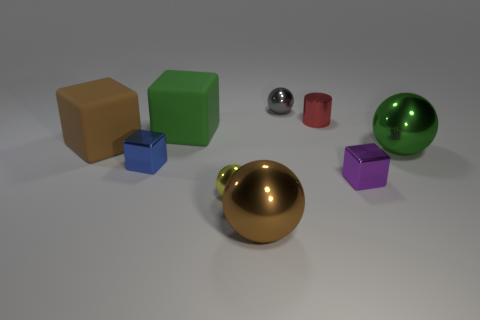Add 1 gray blocks. How many objects exist? 10 Subtract all spheres. How many objects are left? 5 Add 7 small blue shiny things. How many small blue shiny things are left? 8 Add 2 tiny yellow metal objects. How many tiny yellow metal objects exist? 3 Subtract 0 yellow cubes. How many objects are left? 9 Subtract all large green spheres. Subtract all large brown blocks. How many objects are left? 7 